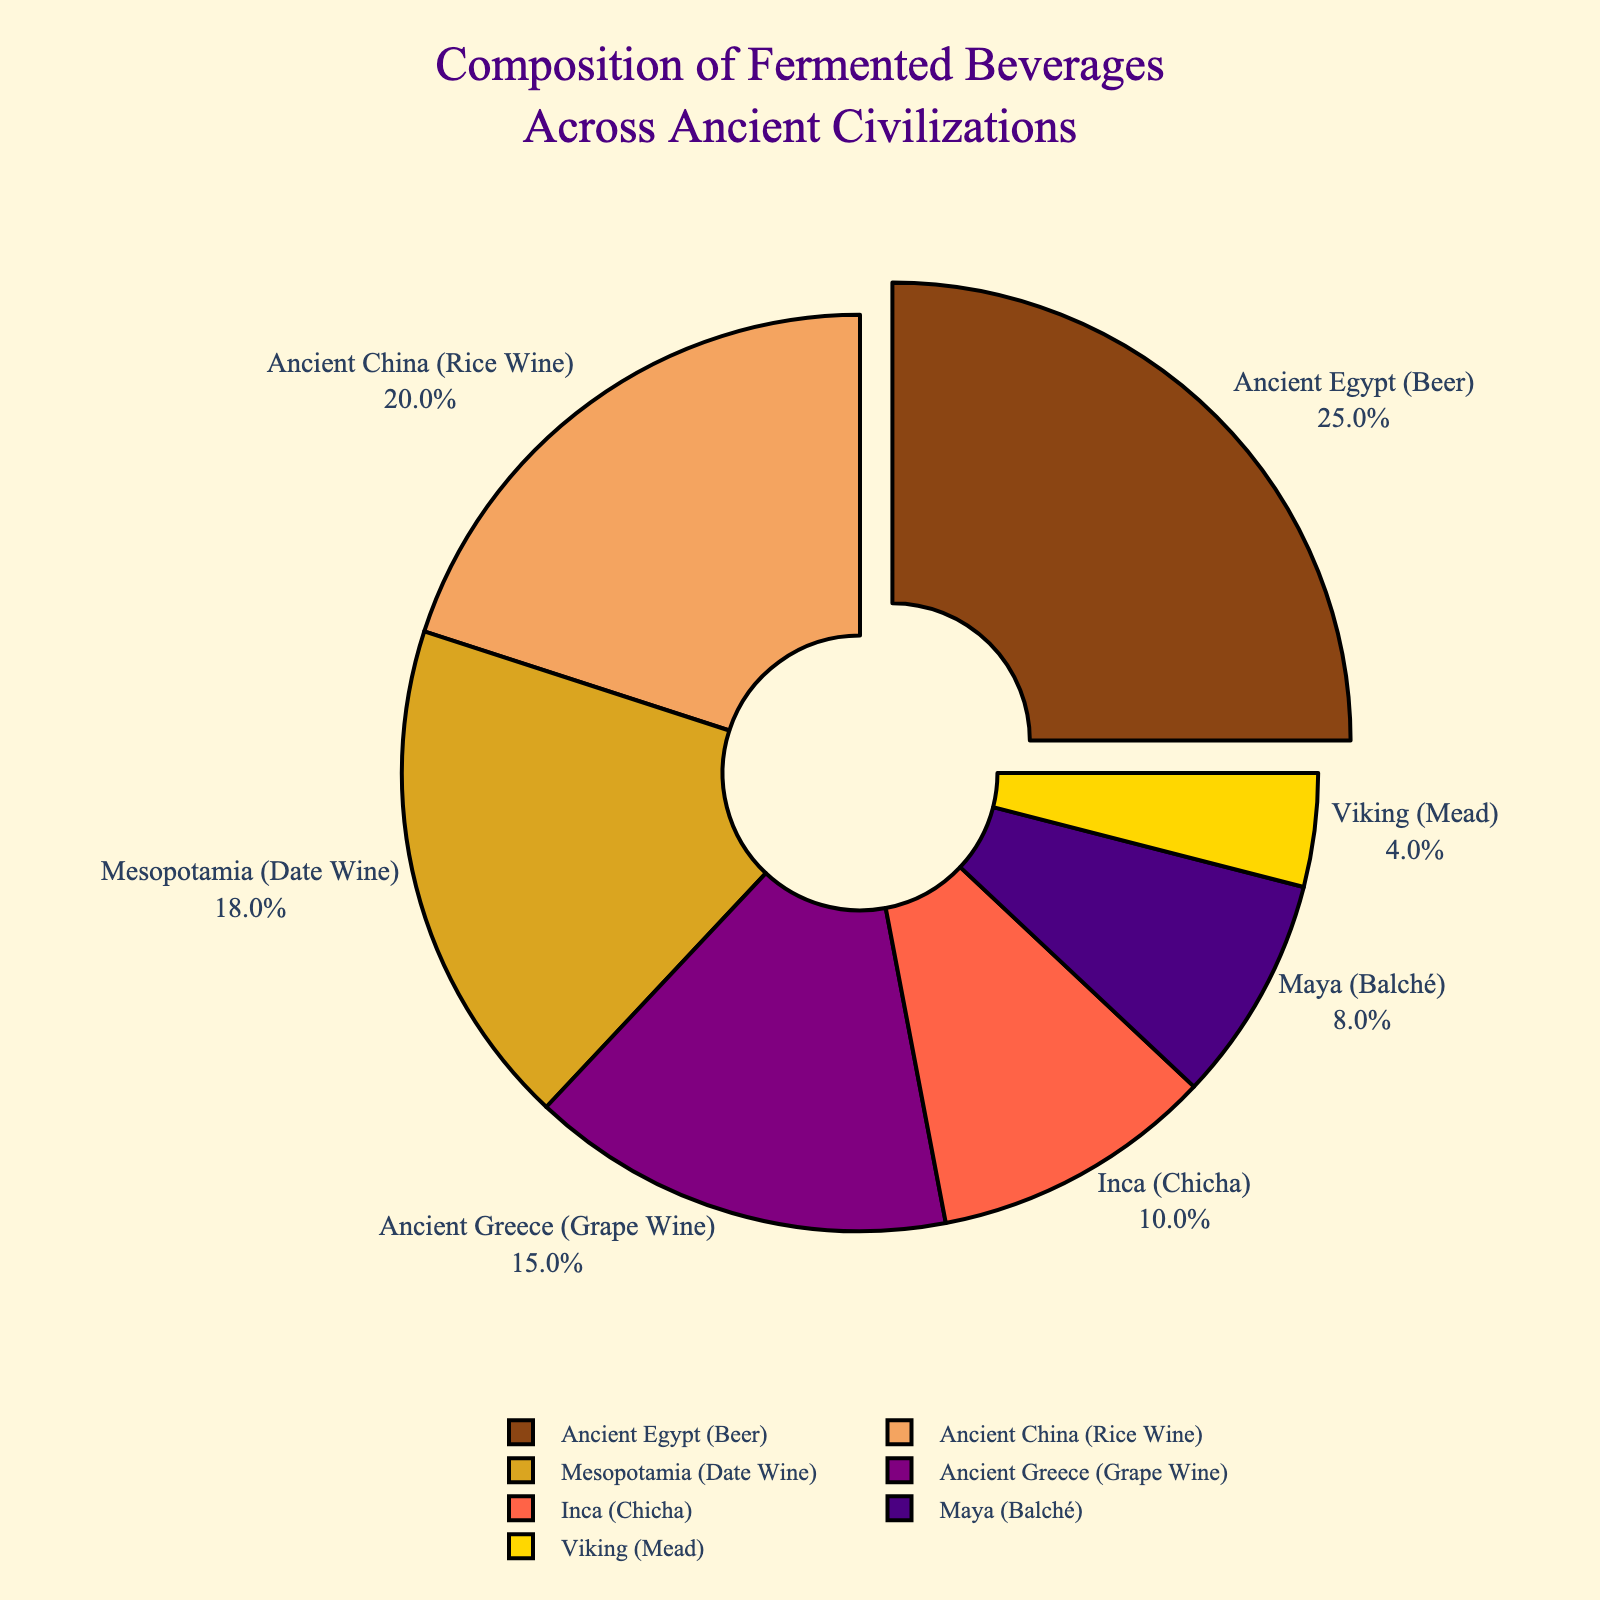What percentage of the fermented beverages came from Ancient Egypt and Mesopotamia combined? To find the combined percentage from Ancient Egypt and Mesopotamia, sum the percentages for each: 25% (Ancient Egypt) + 18% (Mesopotamia) = 43%.
Answer: 43% Which civilization contributed the least to the composition of fermented beverages? The section with the smallest percentage represents the least contribution. The Viking (Mead) with 4% is the smallest on the chart.
Answer: Viking (Mead) Compare the contribution of Ancient Greece and Maya to the composition of fermented beverages. Which is greater, and by how much? The percentage for Ancient Greece is 15%, and for the Maya, it is 8%. Subtract to find the difference: 15% - 8% = 7%. Ancient Greece's contribution is greater.
Answer: Ancient Greece by 7% What color represents the Inca civilization's fermented beverage contribution on the chart? Look at the color label next to "Inca (Chicha)" on the chart. It uses a red color.
Answer: Red What is the difference in percentage between Ancient China and Ancient Egypt's fermented beverages? The percentage for Ancient China is 20%, and for Ancient Egypt, it is 25%. Subtract to find the difference: 25% - 20% = 5%.
Answer: 5% Calculate the average percentage contribution of the ancient civilizations presented in the chart. Sum all the percentages and then divide by the number of civilizations: (25 + 18 + 20 + 15 + 8 + 10 + 4) / 7 = 100 / 7 ≈ 14.3%.
Answer: ≈ 14.3% What is the visual effect applied to the Ancient Egypt section of the pie chart? The Ancient Egypt section is pulled out slightly from the rest of the pie, creating an emphasis effect.
Answer: Pulled out Which three civilizations together contribute exactly half of the total percentage? Find combinations that sum to 50%. Ancient Egypt (25%) + Mesopotamia (18%) + Viking (4%) = 47% (not exact). Ancient Egypt (25%) + Ancient China (20%) + Viking (4%) = 49% (not exact). Ancient Egypt (25%) + Mesopotamia (18%) + Maya (8%) = 51% (not exact). Ancient Egypt (25%) + Mesopotamia (18%) + Inca (10%) = 53% (not exact). Other combinations also don't match exactly 50%.
Answer: No exact match Which contribution is closer to 10%, the Inca or the Maya? The percentage for Inca is 10%, and for the Maya, it is 8%. Since 10% is equal to 10%, the Inca contribution is closer.
Answer: Inca 